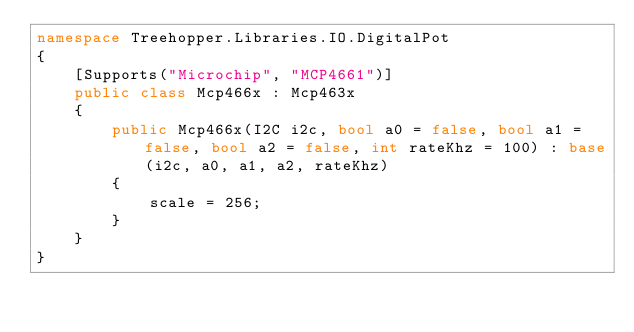Convert code to text. <code><loc_0><loc_0><loc_500><loc_500><_C#_>namespace Treehopper.Libraries.IO.DigitalPot
{
    [Supports("Microchip", "MCP4661")]
    public class Mcp466x : Mcp463x
    {
        public Mcp466x(I2C i2c, bool a0 = false, bool a1 = false, bool a2 = false, int rateKhz = 100) : base(i2c, a0, a1, a2, rateKhz)
        {
            scale = 256;
        }
    }
}</code> 